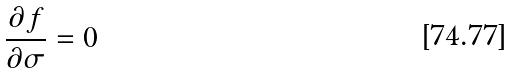<formula> <loc_0><loc_0><loc_500><loc_500>\frac { \partial f } { \partial \sigma } = 0</formula> 